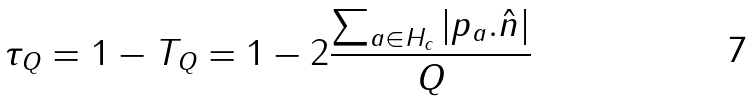Convert formula to latex. <formula><loc_0><loc_0><loc_500><loc_500>\tau _ { Q } = 1 - T _ { Q } = 1 - 2 \frac { \sum _ { a \in H _ { c } } | p _ { a } . \hat { n } | } { Q }</formula> 